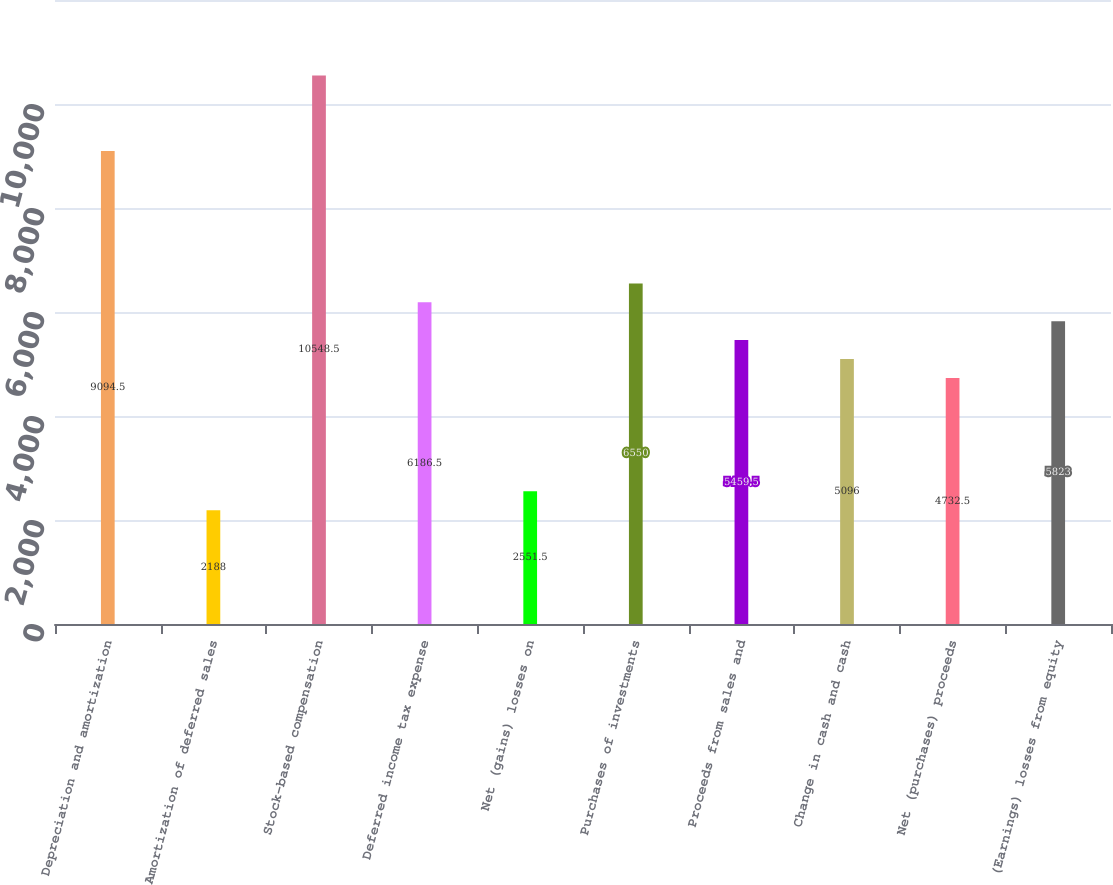<chart> <loc_0><loc_0><loc_500><loc_500><bar_chart><fcel>Depreciation and amortization<fcel>Amortization of deferred sales<fcel>Stock-based compensation<fcel>Deferred income tax expense<fcel>Net (gains) losses on<fcel>Purchases of investments<fcel>Proceeds from sales and<fcel>Change in cash and cash<fcel>Net (purchases) proceeds<fcel>(Earnings) losses from equity<nl><fcel>9094.5<fcel>2188<fcel>10548.5<fcel>6186.5<fcel>2551.5<fcel>6550<fcel>5459.5<fcel>5096<fcel>4732.5<fcel>5823<nl></chart> 